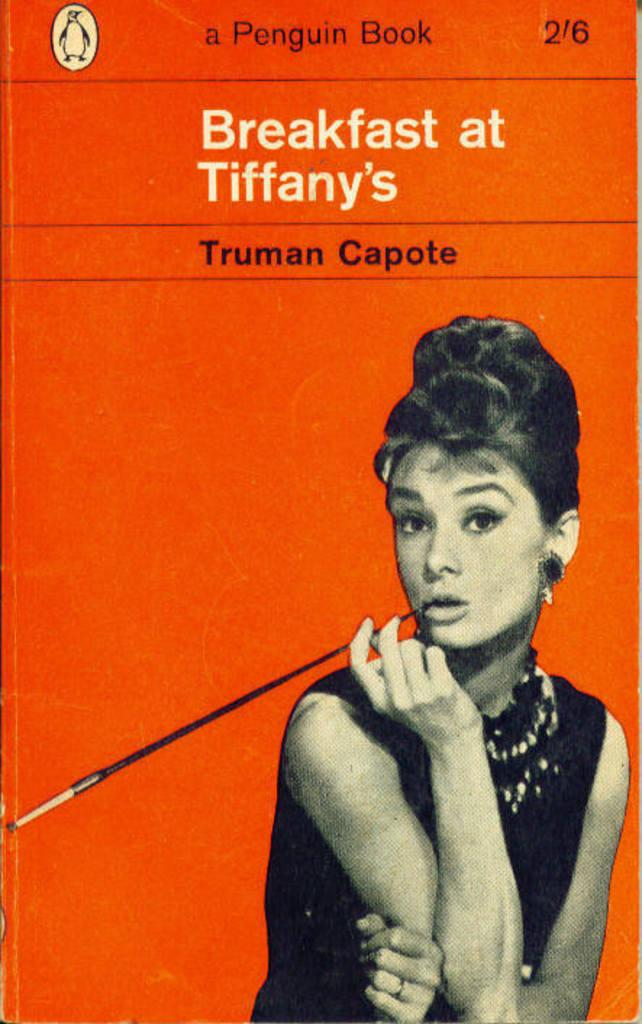What is depicted on the poster in the image? There is a woman's image on the poster. What else can be seen on the poster besides the woman's image? There is text written on the poster. What is the woman wearing in the image? The woman is wearing a black dress. What is the woman holding in her hand in the image? The woman is holding a stick in her hand. How does the woman measure the heat in the image? There is no indication in the image that the woman is measuring heat, nor is there any device present for such a purpose. 